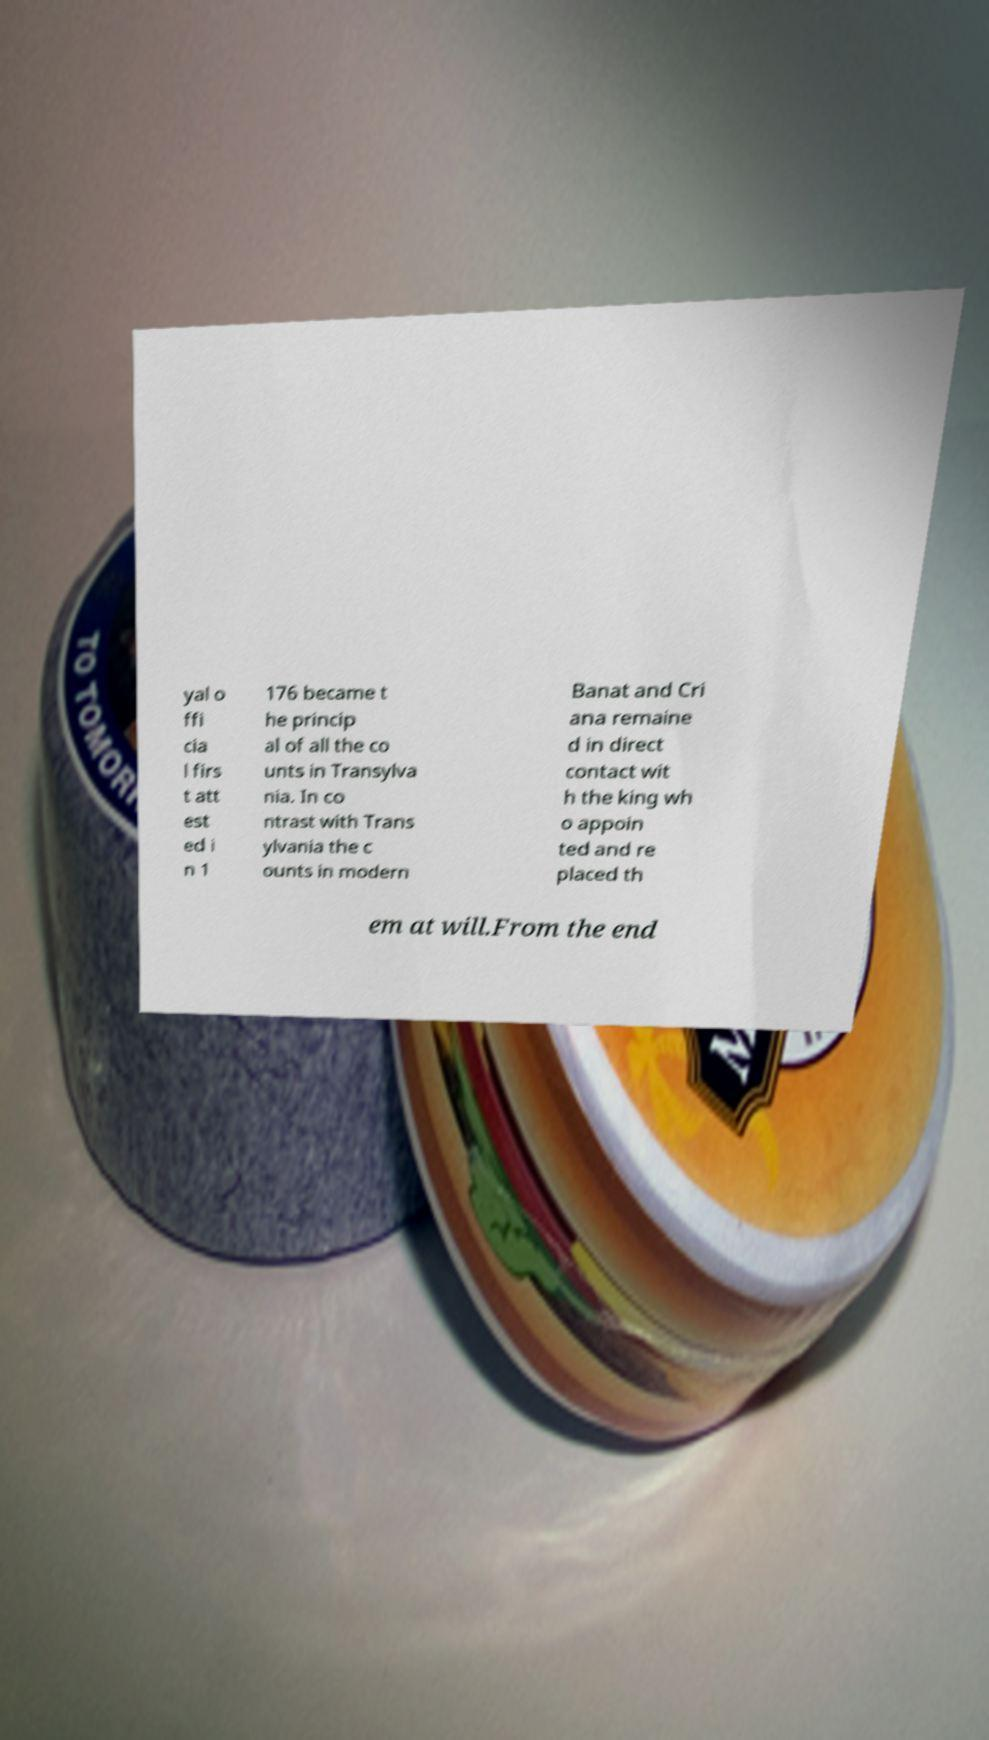Could you extract and type out the text from this image? yal o ffi cia l firs t att est ed i n 1 176 became t he princip al of all the co unts in Transylva nia. In co ntrast with Trans ylvania the c ounts in modern Banat and Cri ana remaine d in direct contact wit h the king wh o appoin ted and re placed th em at will.From the end 